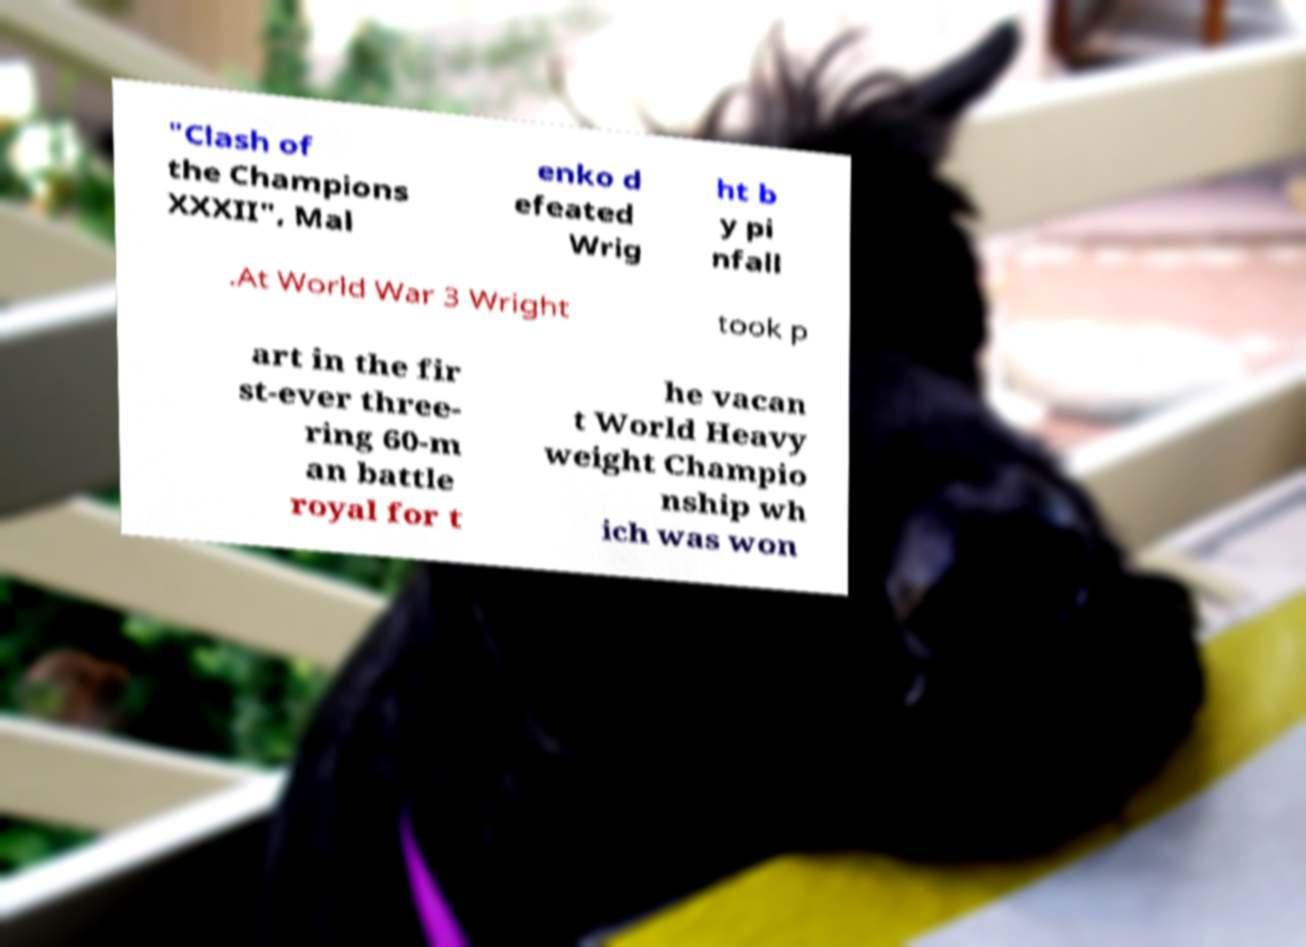What messages or text are displayed in this image? I need them in a readable, typed format. "Clash of the Champions XXXII", Mal enko d efeated Wrig ht b y pi nfall .At World War 3 Wright took p art in the fir st-ever three- ring 60-m an battle royal for t he vacan t World Heavy weight Champio nship wh ich was won 